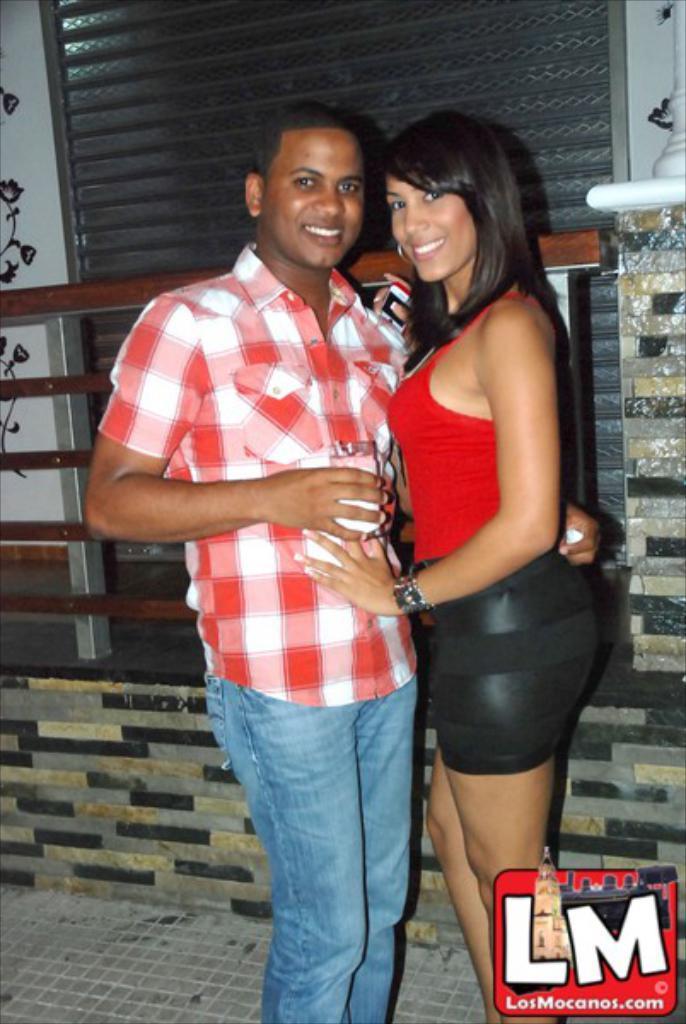In one or two sentences, can you explain what this image depicts? In the background we can see the wall, object, railings, pillar. We can see a woman and a man giving a pose. She is holding a mobile and he is holding a glass. They both are smiling. In the bottom right corner of the picture we can see watermark. 